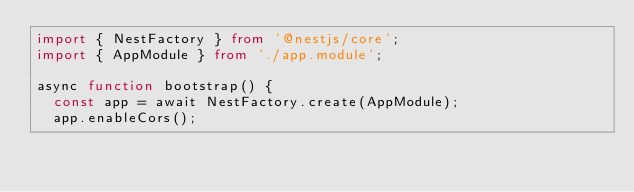<code> <loc_0><loc_0><loc_500><loc_500><_TypeScript_>import { NestFactory } from '@nestjs/core';
import { AppModule } from './app.module';

async function bootstrap() {
  const app = await NestFactory.create(AppModule);
  app.enableCors();</code> 